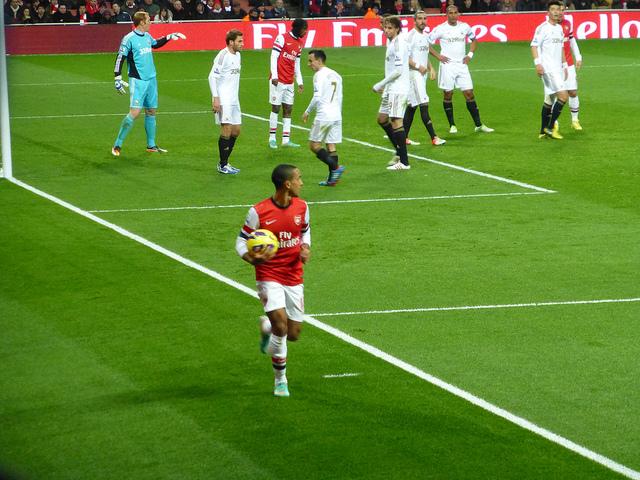What color is the man's shirt who is running on the sideline?
Be succinct. Red. What game are they playing?
Quick response, please. Soccer. What is about to get hit?
Answer briefly. Ball. What color is the ball the man is holding?
Short answer required. Yellow. What are these people playing?
Answer briefly. Soccer. 